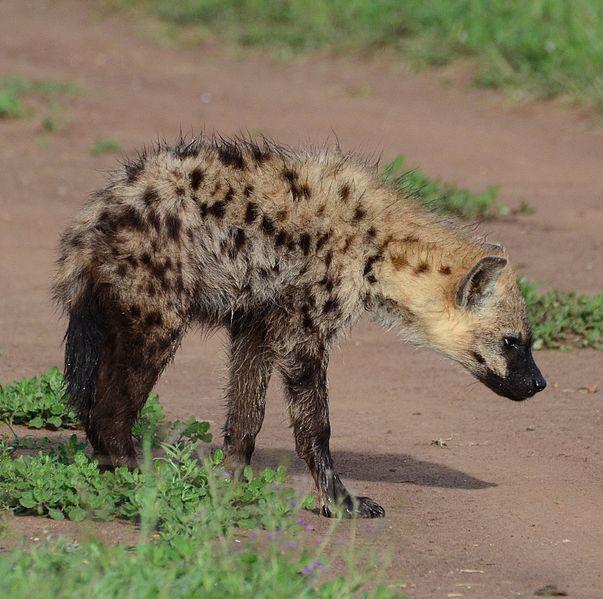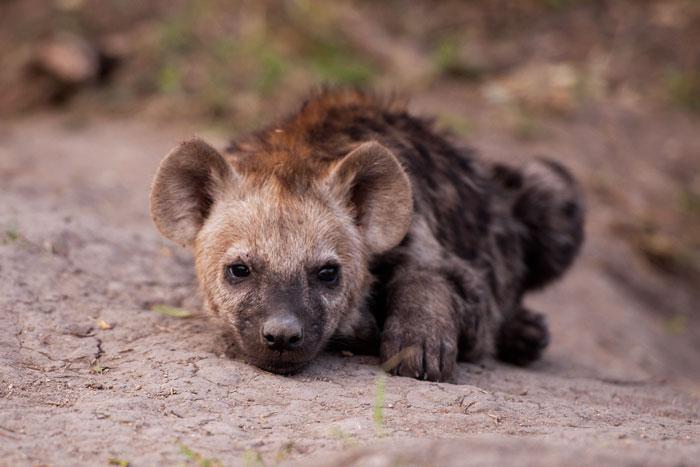The first image is the image on the left, the second image is the image on the right. For the images shown, is this caption "the right side image has only two animals" true? Answer yes or no. No. The first image is the image on the left, the second image is the image on the right. Examine the images to the left and right. Is the description "there are a minimum of 7 hyenas present." accurate? Answer yes or no. No. 